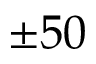<formula> <loc_0><loc_0><loc_500><loc_500>\pm 5 0</formula> 